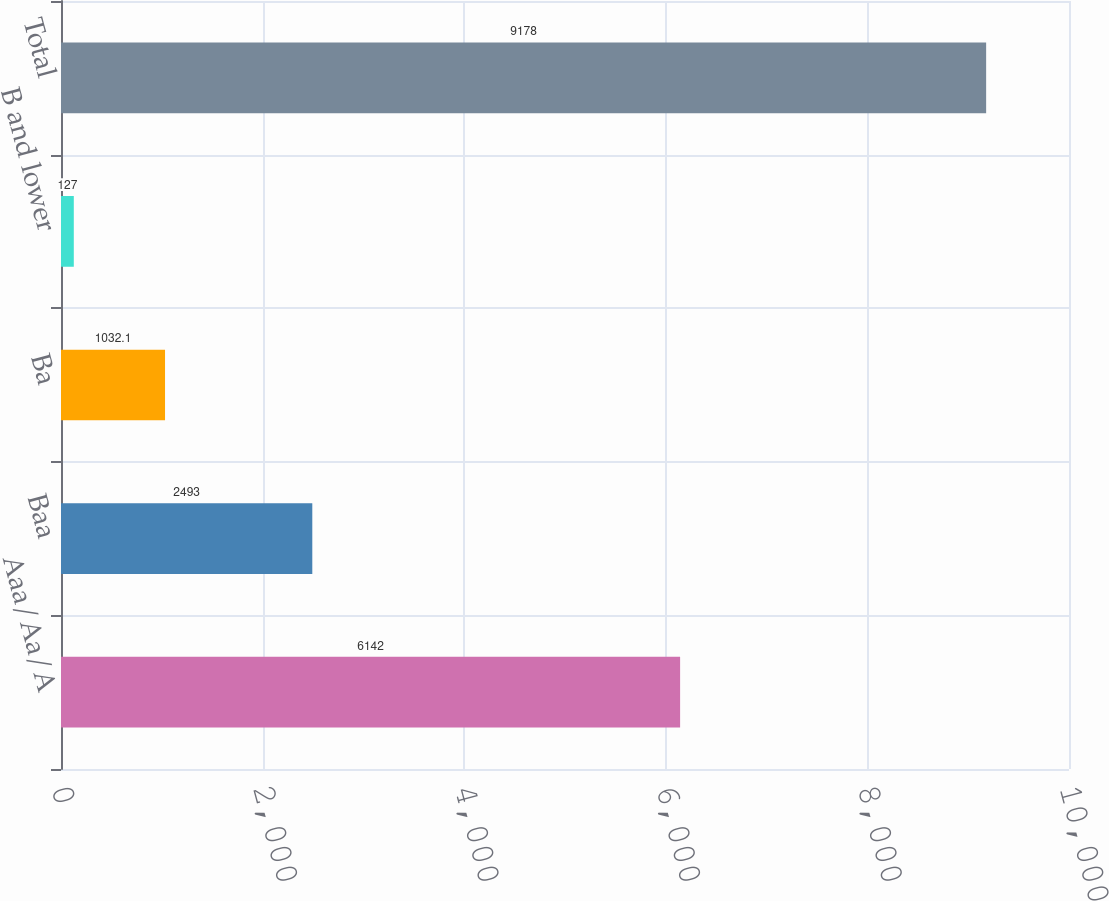Convert chart. <chart><loc_0><loc_0><loc_500><loc_500><bar_chart><fcel>Aaa/Aa/A<fcel>Baa<fcel>Ba<fcel>B and lower<fcel>Total<nl><fcel>6142<fcel>2493<fcel>1032.1<fcel>127<fcel>9178<nl></chart> 